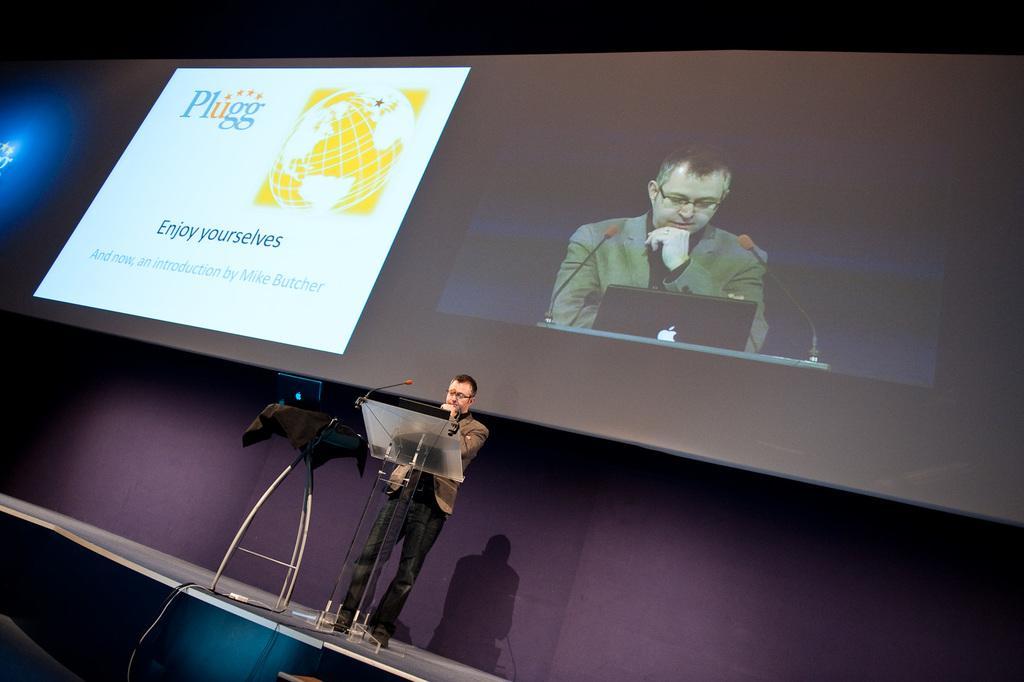In one or two sentences, can you explain what this image depicts? In this image we can see there is a person standing on the bias, beside him there is a laptop on the table. In the background there is a screen. On the screen we can see this person standing on the bias and some text beside him. 